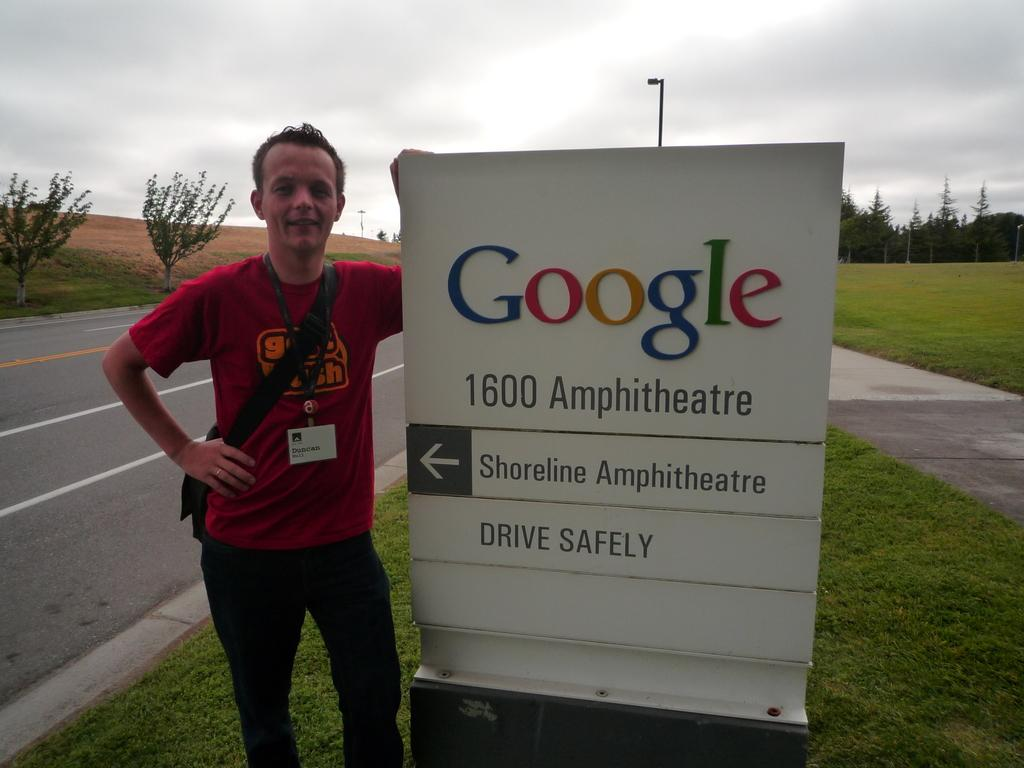Provide a one-sentence caption for the provided image. Duncan Hull stands next to a Google sign located at 1600 Amphitheatre.. 